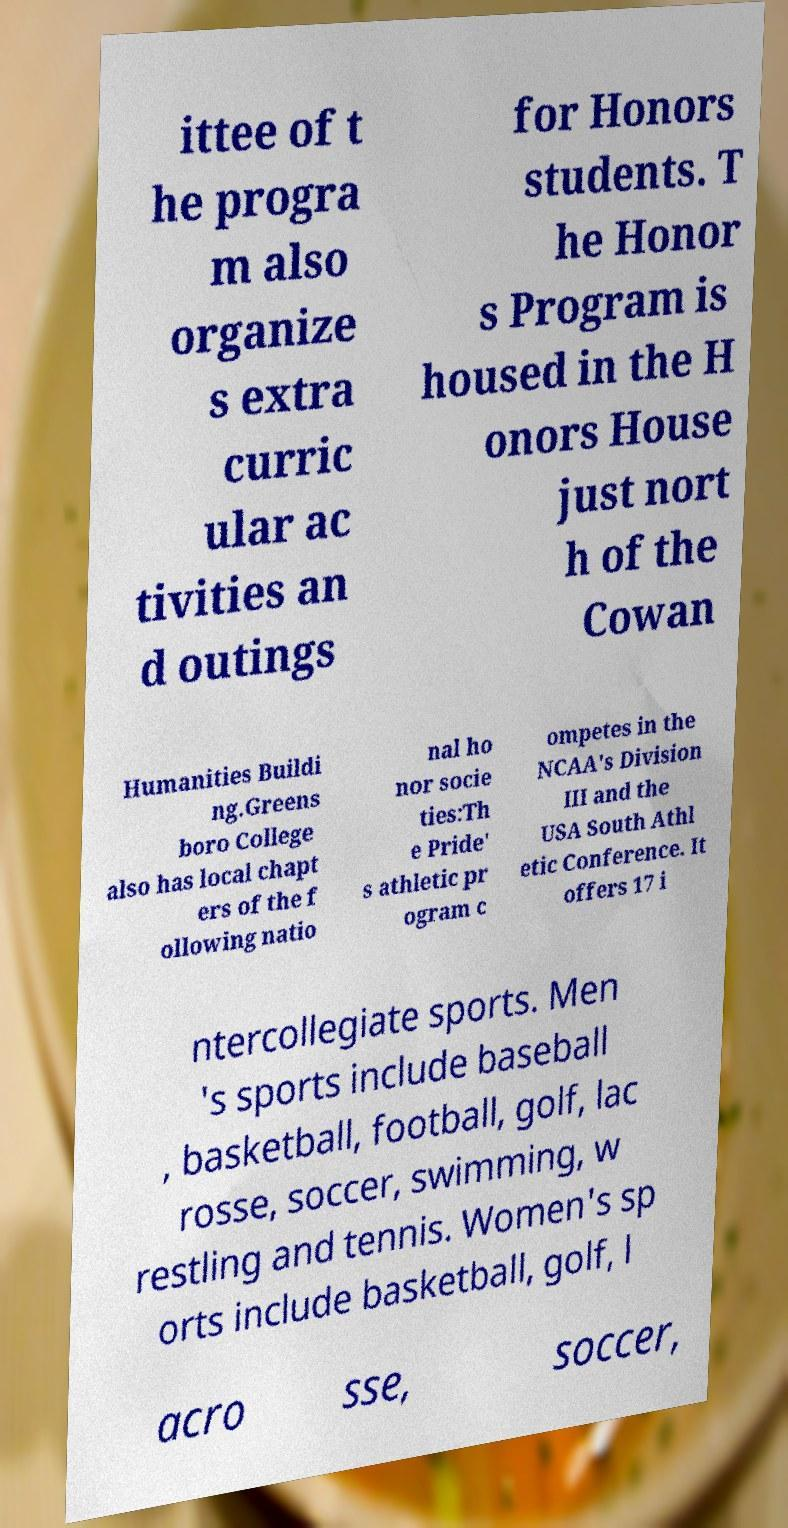Can you read and provide the text displayed in the image?This photo seems to have some interesting text. Can you extract and type it out for me? ittee of t he progra m also organize s extra curric ular ac tivities an d outings for Honors students. T he Honor s Program is housed in the H onors House just nort h of the Cowan Humanities Buildi ng.Greens boro College also has local chapt ers of the f ollowing natio nal ho nor socie ties:Th e Pride' s athletic pr ogram c ompetes in the NCAA's Division III and the USA South Athl etic Conference. It offers 17 i ntercollegiate sports. Men 's sports include baseball , basketball, football, golf, lac rosse, soccer, swimming, w restling and tennis. Women's sp orts include basketball, golf, l acro sse, soccer, 